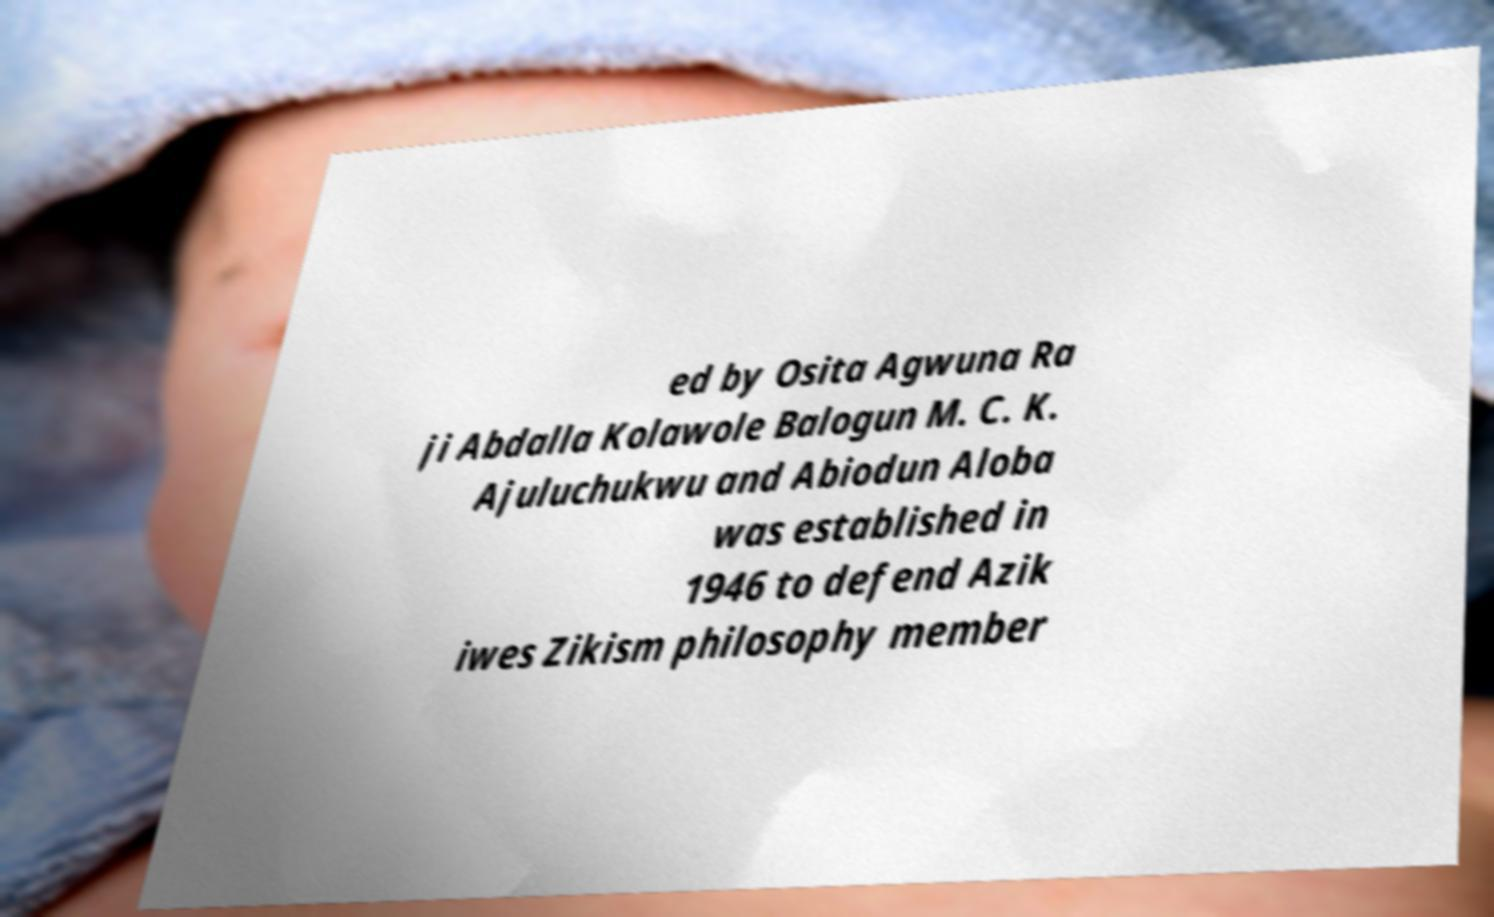Please read and relay the text visible in this image. What does it say? ed by Osita Agwuna Ra ji Abdalla Kolawole Balogun M. C. K. Ajuluchukwu and Abiodun Aloba was established in 1946 to defend Azik iwes Zikism philosophy member 